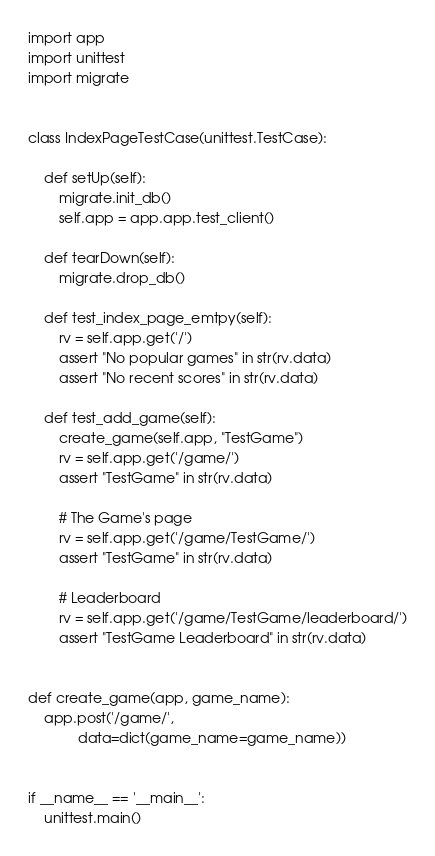<code> <loc_0><loc_0><loc_500><loc_500><_Python_>import app
import unittest
import migrate


class IndexPageTestCase(unittest.TestCase):

    def setUp(self):
        migrate.init_db()
        self.app = app.app.test_client()

    def tearDown(self):
        migrate.drop_db()

    def test_index_page_emtpy(self):
        rv = self.app.get('/')
        assert "No popular games" in str(rv.data)
        assert "No recent scores" in str(rv.data)

    def test_add_game(self):
        create_game(self.app, "TestGame")
        rv = self.app.get('/game/')
        assert "TestGame" in str(rv.data)

        # The Game's page
        rv = self.app.get('/game/TestGame/')
        assert "TestGame" in str(rv.data)

        # Leaderboard
        rv = self.app.get('/game/TestGame/leaderboard/')
        assert "TestGame Leaderboard" in str(rv.data)


def create_game(app, game_name):
    app.post('/game/',
             data=dict(game_name=game_name))


if __name__ == '__main__':
    unittest.main()
</code> 